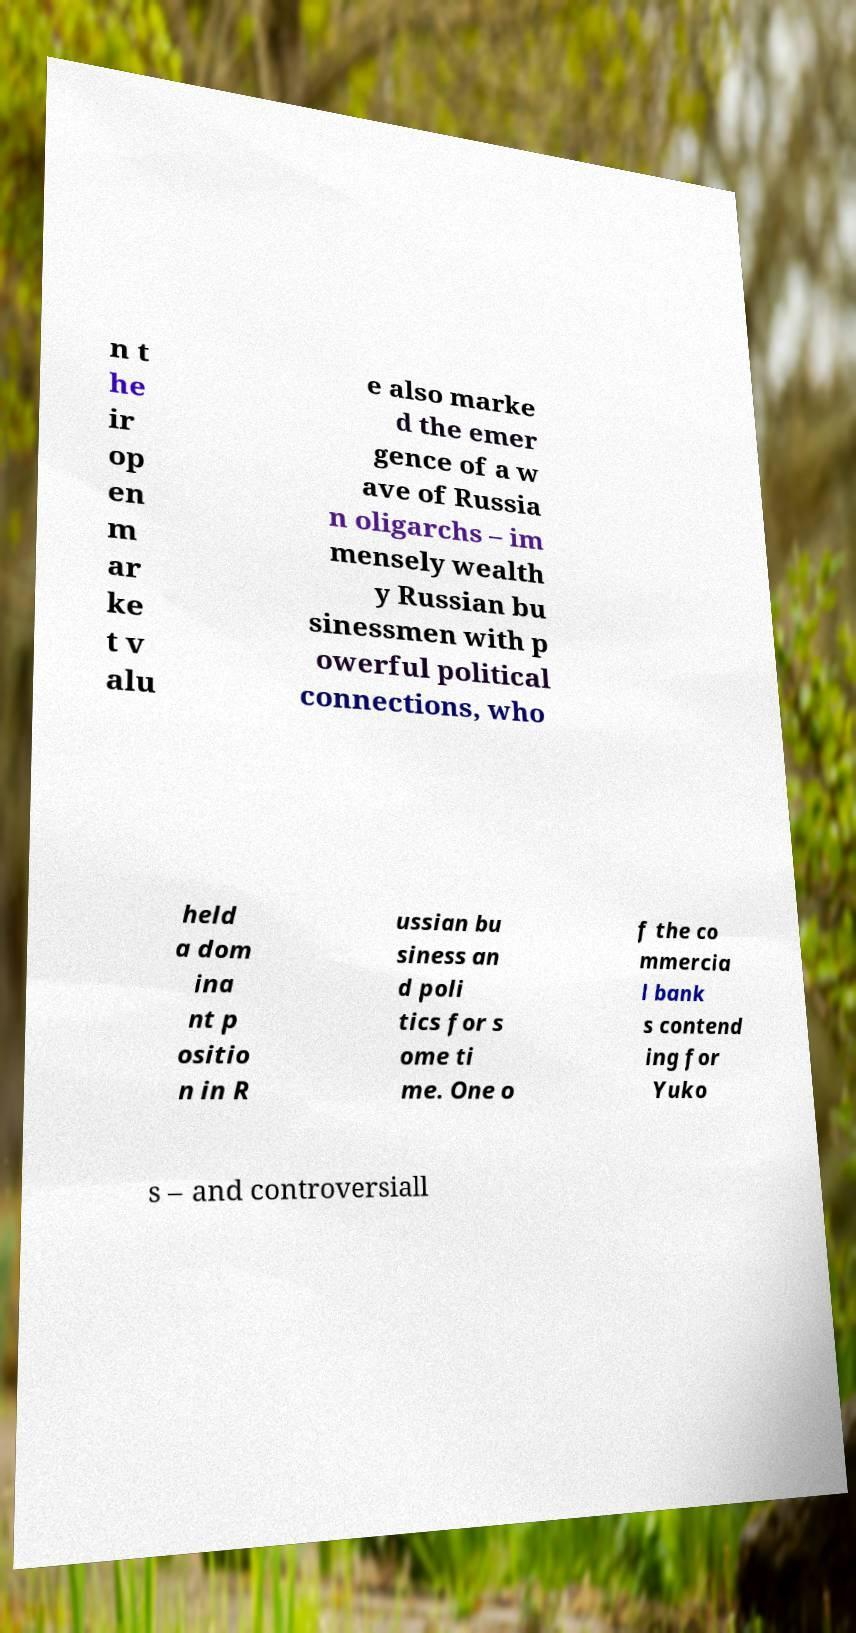What messages or text are displayed in this image? I need them in a readable, typed format. n t he ir op en m ar ke t v alu e also marke d the emer gence of a w ave of Russia n oligarchs – im mensely wealth y Russian bu sinessmen with p owerful political connections, who held a dom ina nt p ositio n in R ussian bu siness an d poli tics for s ome ti me. One o f the co mmercia l bank s contend ing for Yuko s – and controversiall 